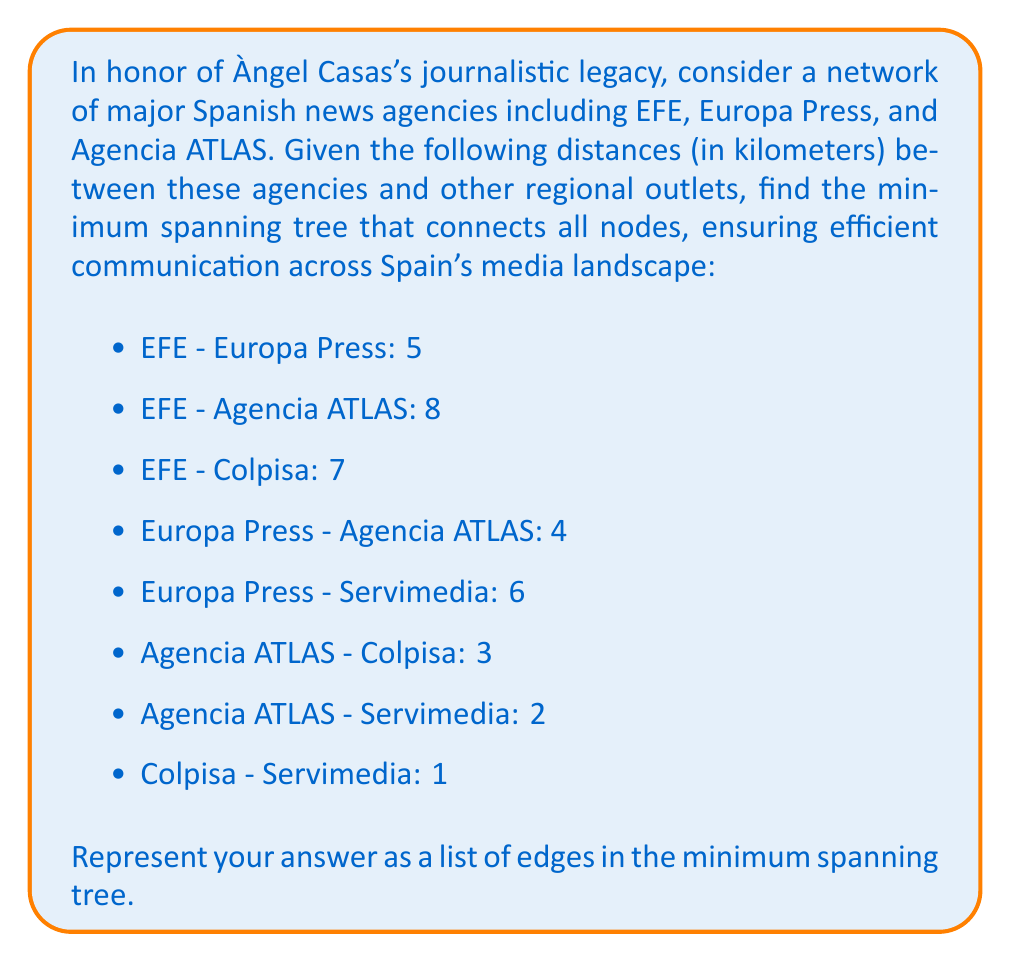Help me with this question. To solve this problem, we can use Kruskal's algorithm to find the minimum spanning tree (MST) of the given graph. Here's a step-by-step approach:

1) First, let's list all edges and their weights in ascending order:
   Colpisa - Servimedia: 1
   Agencia ATLAS - Servimedia: 2
   Agencia ATLAS - Colpisa: 3
   Europa Press - Agencia ATLAS: 4
   EFE - Europa Press: 5
   Europa Press - Servimedia: 6
   EFE - Colpisa: 7
   EFE - Agencia ATLAS: 8

2) Now, we'll apply Kruskal's algorithm:
   a) Start with an empty set of edges.
   b) Add the edge with the smallest weight that doesn't create a cycle.
   c) Repeat step b until we have $n-1$ edges, where $n$ is the number of nodes.

3) Following the algorithm:
   - Add Colpisa - Servimedia (1)
   - Add Agencia ATLAS - Servimedia (2)
   - Add Agencia ATLAS - Colpisa (3) (skip, as it would create a cycle)
   - Add Europa Press - Agencia ATLAS (4)
   - Add EFE - Europa Press (5)

4) At this point, we have 4 edges connecting 5 nodes, which is sufficient for our MST.

The total weight of this MST is:
$$1 + 2 + 4 + 5 = 12$$

This represents the most efficient way to connect all the news agencies in the network.
Answer: The minimum spanning tree consists of the following edges:
1. Colpisa - Servimedia
2. Agencia ATLAS - Servimedia
3. Europa Press - Agencia ATLAS
4. EFE - Europa Press 